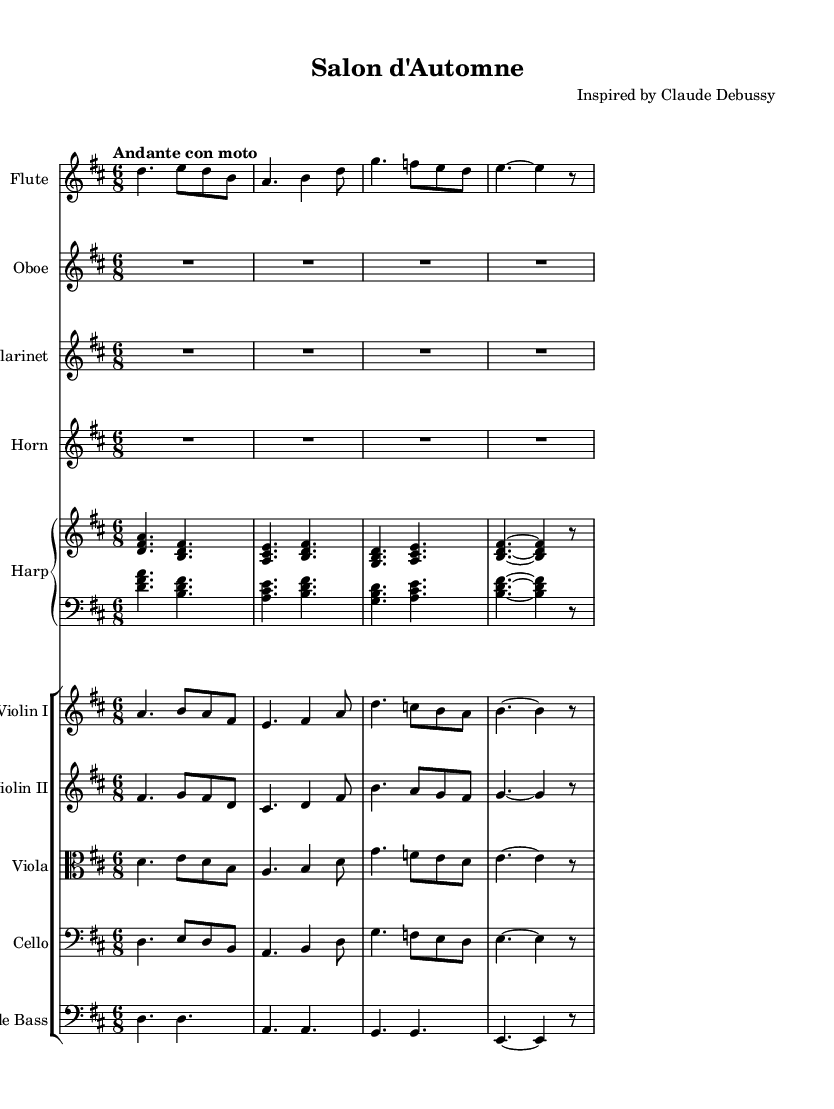What is the key signature of this symphony? The key signature is D major, which has two sharps (F# and C#). This can be observed in the key signature at the beginning of the staff.
Answer: D major What is the time signature of this piece? The time signature is 6/8, which indicates there are six eighth notes per measure. This can be seen just after the key signature at the beginning of the score.
Answer: 6/8 What is the tempo marking of this symphony? The tempo marking is "Andante con moto", which indicates a moderately slow pace with a bit of movement. This is written near the beginning of the score.
Answer: Andante con moto How many different instruments are included in this performance? There are eight instruments in total, as identified by the different staves in the score: Flute, Oboe, Clarinet, Horn, Harp, Violin I, Violin II, Viola, Cello, and Double Bass.
Answer: Eight Which instrument performs the first melodic entrance? The Flute plays the first melodic entrance, which is indicated by the first staff and begins with a series of notes following the global settings.
Answer: Flute What is the range of the Violin I part? The Violin I part ranges from A4 to B5, encompassing a full octave with various rhythmic figures displayed in the provided measures. The notes can be traced visually in the staff for Violin I.
Answer: A4 to B5 Which instruments play harmonically along with the Harp? The Harp is harmonically accompanied by the strings: Violin I, Violin II, Viola, Cello, and Double Bass. This arrangement is evident in the placement of the staves in the score.
Answer: Strings 